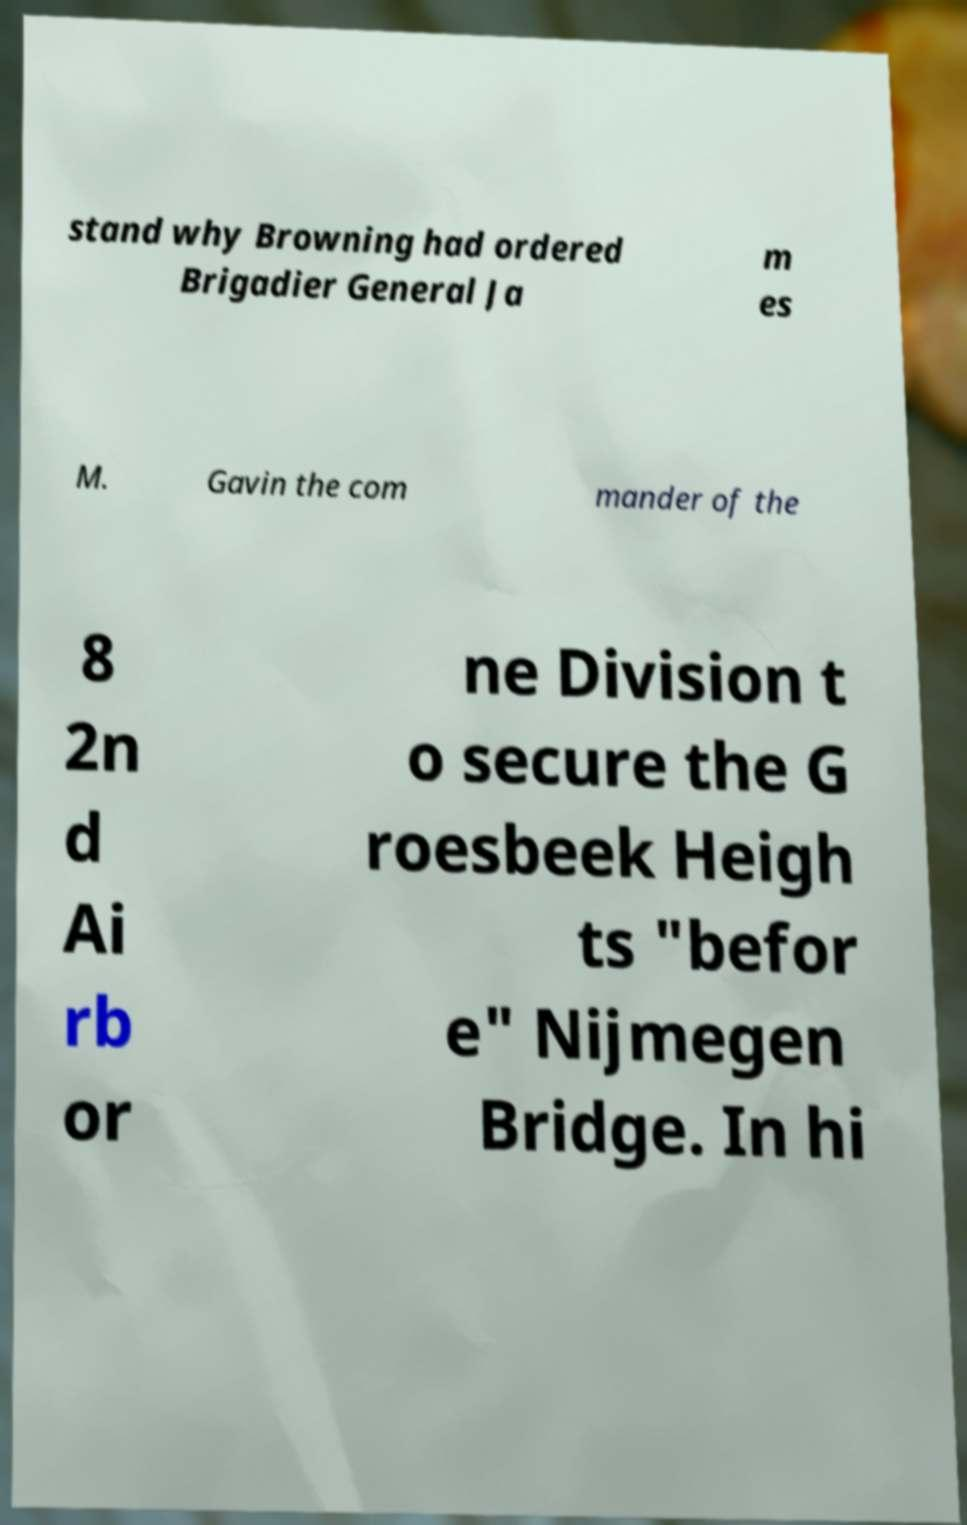Please identify and transcribe the text found in this image. stand why Browning had ordered Brigadier General Ja m es M. Gavin the com mander of the 8 2n d Ai rb or ne Division t o secure the G roesbeek Heigh ts "befor e" Nijmegen Bridge. In hi 